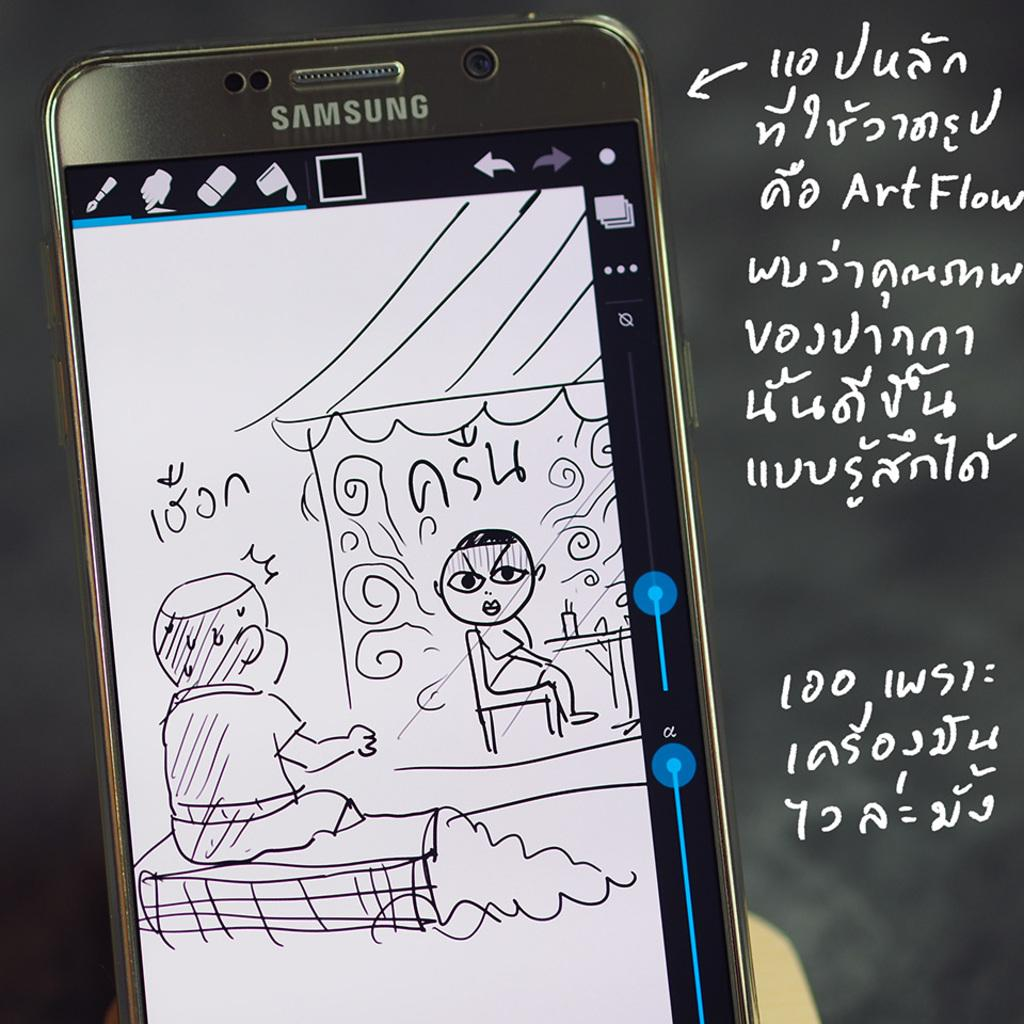<image>
Write a terse but informative summary of the picture. A Samsung device showing a cartoon on the screen and some foreign language words next to it. 